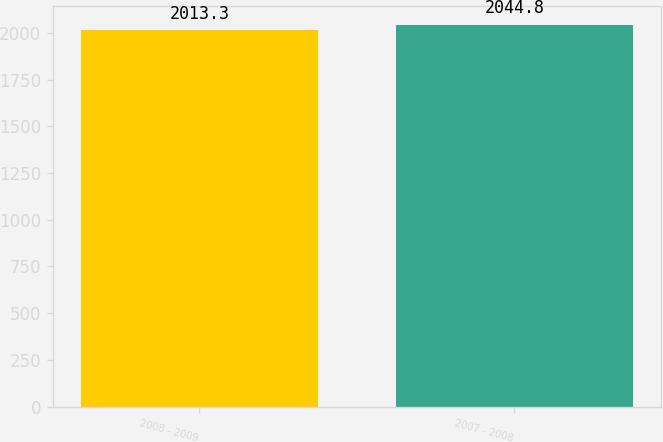Convert chart. <chart><loc_0><loc_0><loc_500><loc_500><bar_chart><fcel>2008 - 2009<fcel>2007 - 2008<nl><fcel>2013.3<fcel>2044.8<nl></chart> 